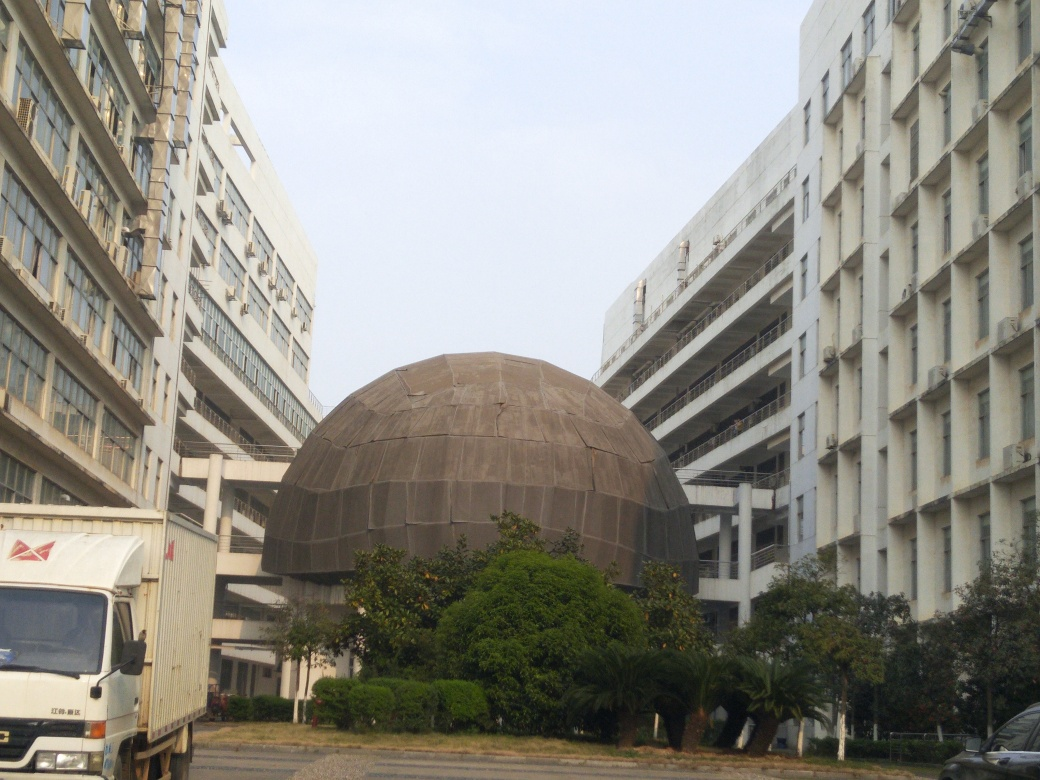What is the architectural style of the buildings in this image? The buildings in the image exhibit features of modernist architecture, characterized by minimalist construction and functional design, with little to no decorative elements. The boxy, repetitive patterns, and use of concrete and steel reinforce the modernist style. The dome structure deviates from the typical modernist design and adds a unique characteristic to the setting. 